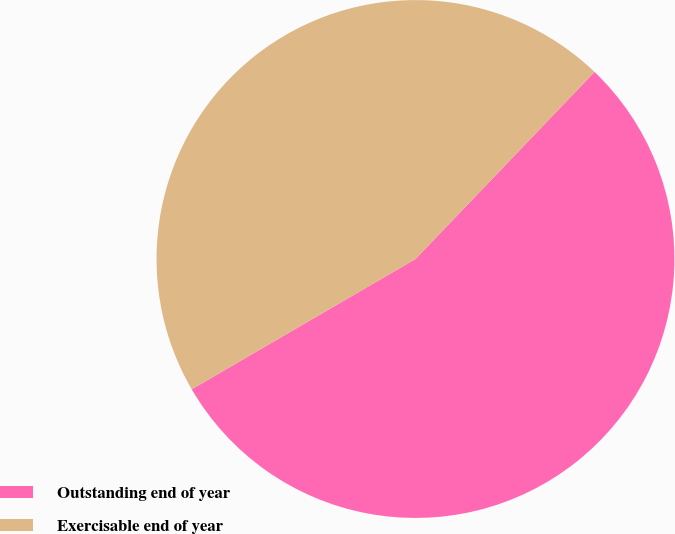Convert chart to OTSL. <chart><loc_0><loc_0><loc_500><loc_500><pie_chart><fcel>Outstanding end of year<fcel>Exercisable end of year<nl><fcel>54.46%<fcel>45.54%<nl></chart> 